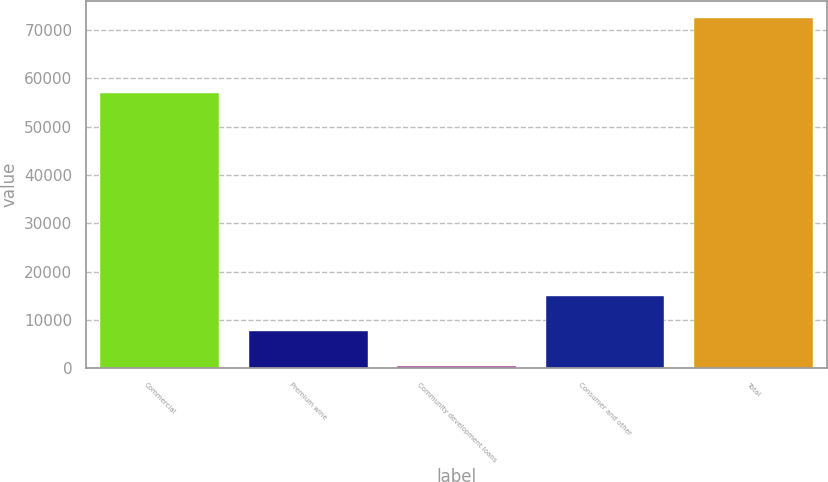Convert chart. <chart><loc_0><loc_0><loc_500><loc_500><bar_chart><fcel>Commercial<fcel>Premium wine<fcel>Community development loans<fcel>Consumer and other<fcel>Total<nl><fcel>56947<fcel>7692.3<fcel>497<fcel>14887.6<fcel>72450<nl></chart> 